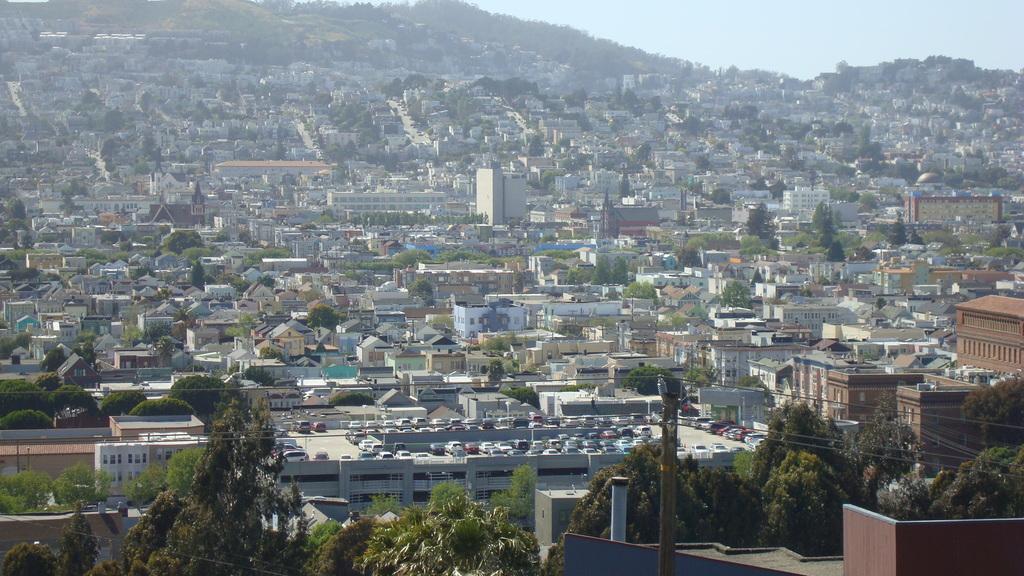Describe this image in one or two sentences. In this image we can see buildings, trees, a current pole with wires and few cars parked in the parking area and sky in the background. 